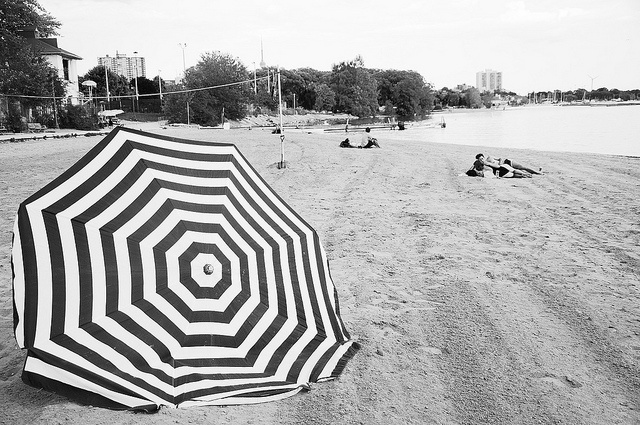Describe the objects in this image and their specific colors. I can see umbrella in black, white, gray, and darkgray tones, people in black, lightgray, darkgray, and gray tones, people in black, lightgray, darkgray, and gray tones, people in black, lightgray, darkgray, and gray tones, and people in black, gray, darkgray, and lightgray tones in this image. 